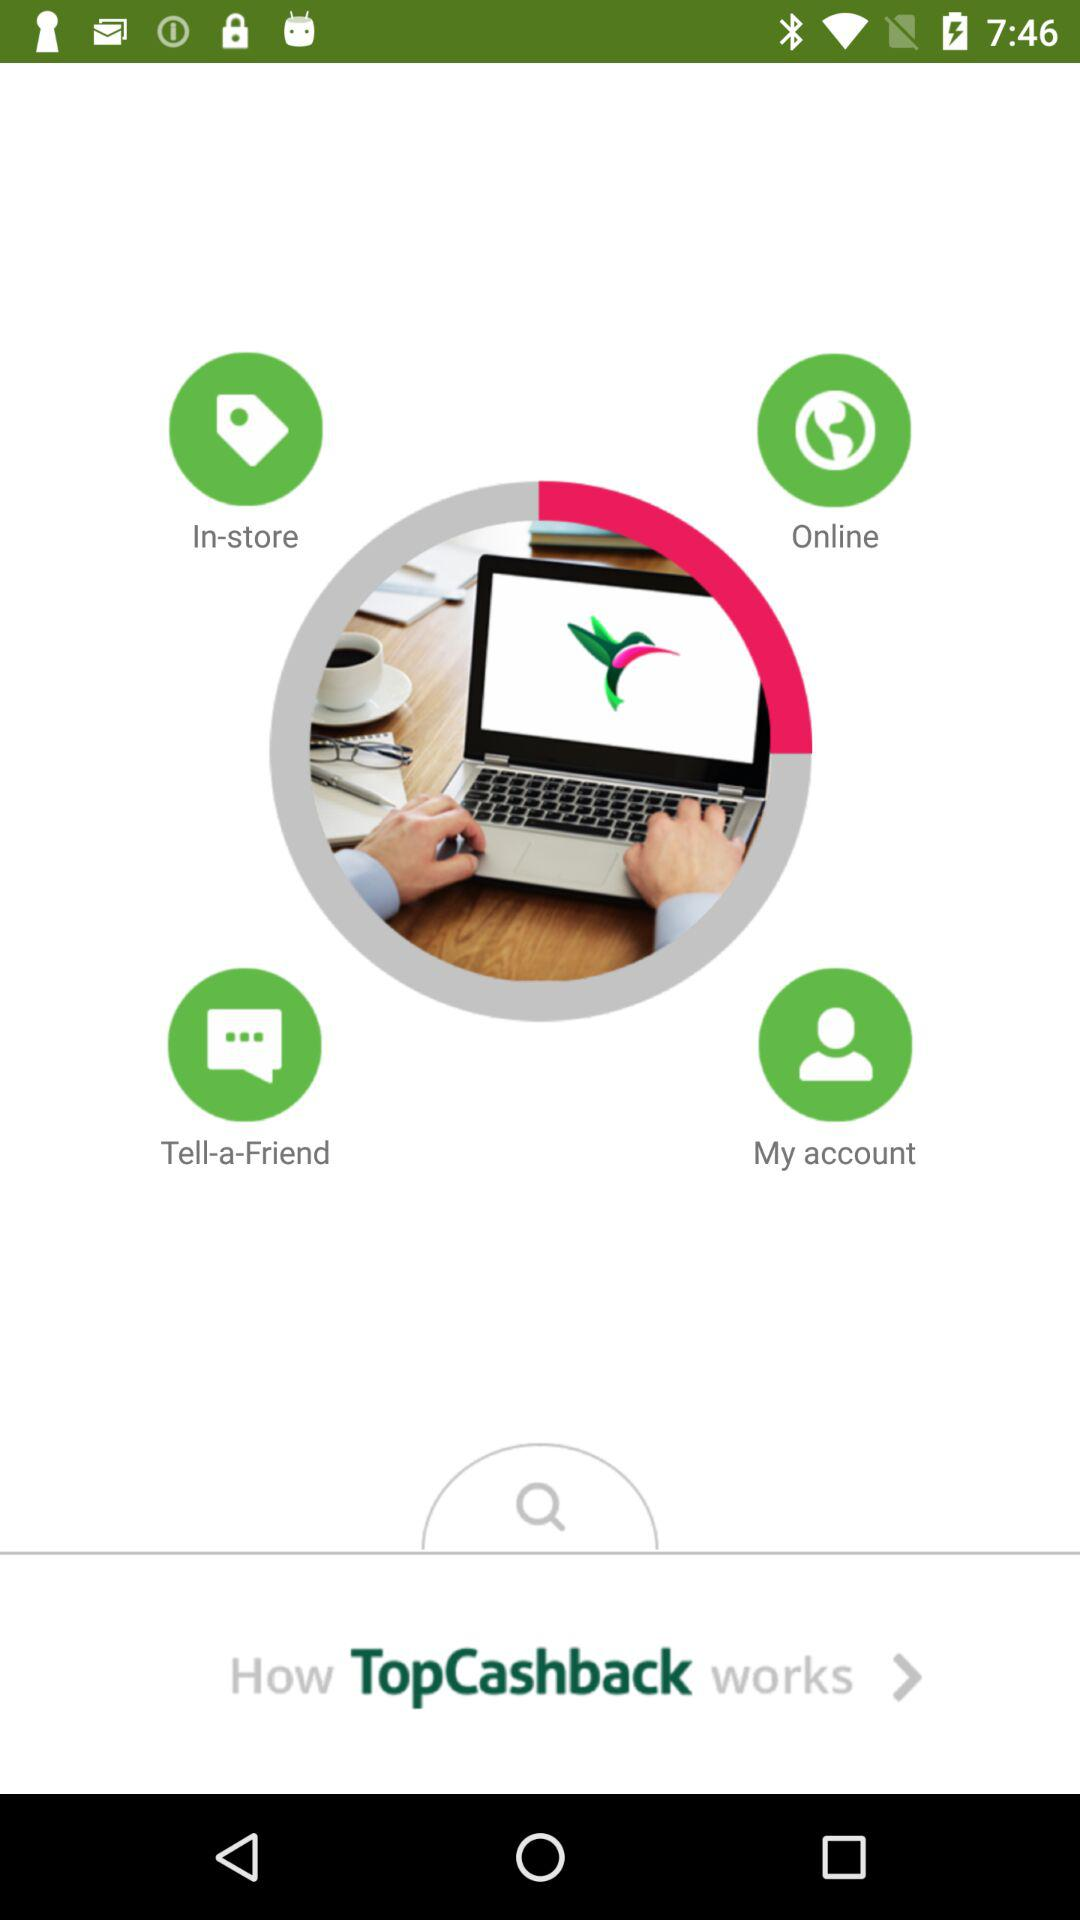What is the app name? The app name is "TopCashback". 